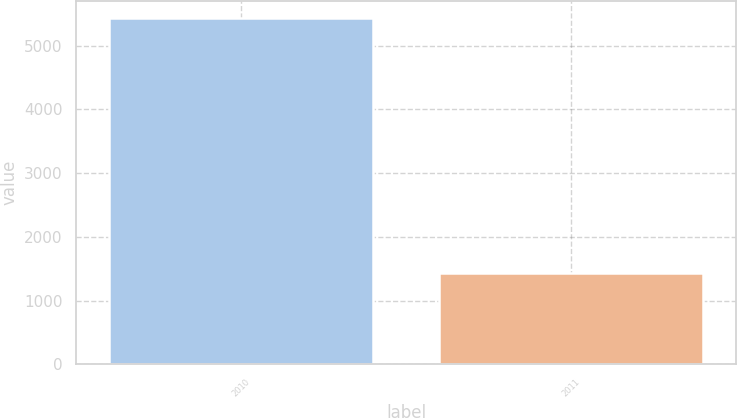Convert chart. <chart><loc_0><loc_0><loc_500><loc_500><bar_chart><fcel>2010<fcel>2011<nl><fcel>5425<fcel>1430<nl></chart> 